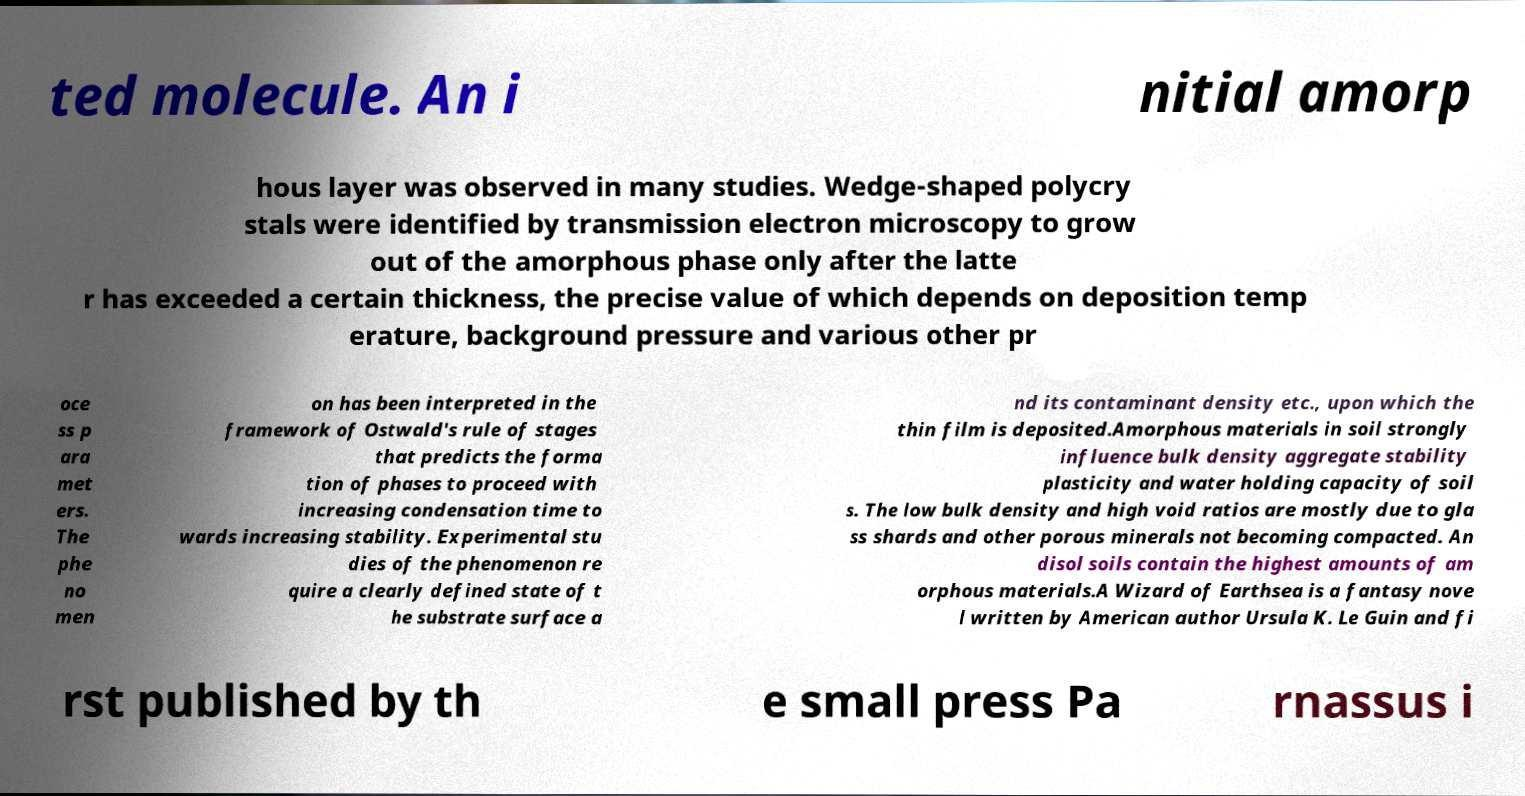Could you assist in decoding the text presented in this image and type it out clearly? ted molecule. An i nitial amorp hous layer was observed in many studies. Wedge-shaped polycry stals were identified by transmission electron microscopy to grow out of the amorphous phase only after the latte r has exceeded a certain thickness, the precise value of which depends on deposition temp erature, background pressure and various other pr oce ss p ara met ers. The phe no men on has been interpreted in the framework of Ostwald's rule of stages that predicts the forma tion of phases to proceed with increasing condensation time to wards increasing stability. Experimental stu dies of the phenomenon re quire a clearly defined state of t he substrate surface a nd its contaminant density etc., upon which the thin film is deposited.Amorphous materials in soil strongly influence bulk density aggregate stability plasticity and water holding capacity of soil s. The low bulk density and high void ratios are mostly due to gla ss shards and other porous minerals not becoming compacted. An disol soils contain the highest amounts of am orphous materials.A Wizard of Earthsea is a fantasy nove l written by American author Ursula K. Le Guin and fi rst published by th e small press Pa rnassus i 